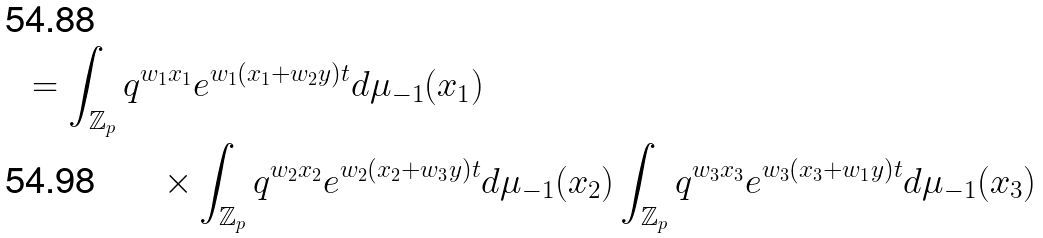<formula> <loc_0><loc_0><loc_500><loc_500>= \int _ { \mathbb { Z } _ { p } } q ^ { w _ { 1 } x _ { 1 } } & e ^ { w _ { 1 } ( x _ { 1 } + w _ { 2 } y ) t } d \mu _ { - 1 } ( x _ { 1 } ) \\ \times & \int _ { \mathbb { Z } _ { p } } q ^ { w _ { 2 } x _ { 2 } } e ^ { w _ { 2 } ( x _ { 2 } + w _ { 3 } y ) t } d \mu _ { - 1 } ( x _ { 2 } ) \int _ { \mathbb { Z } _ { p } } q ^ { w _ { 3 } x _ { 3 } } e ^ { w _ { 3 } ( x _ { 3 } + w _ { 1 } y ) t } d \mu _ { - 1 } ( x _ { 3 } )</formula> 